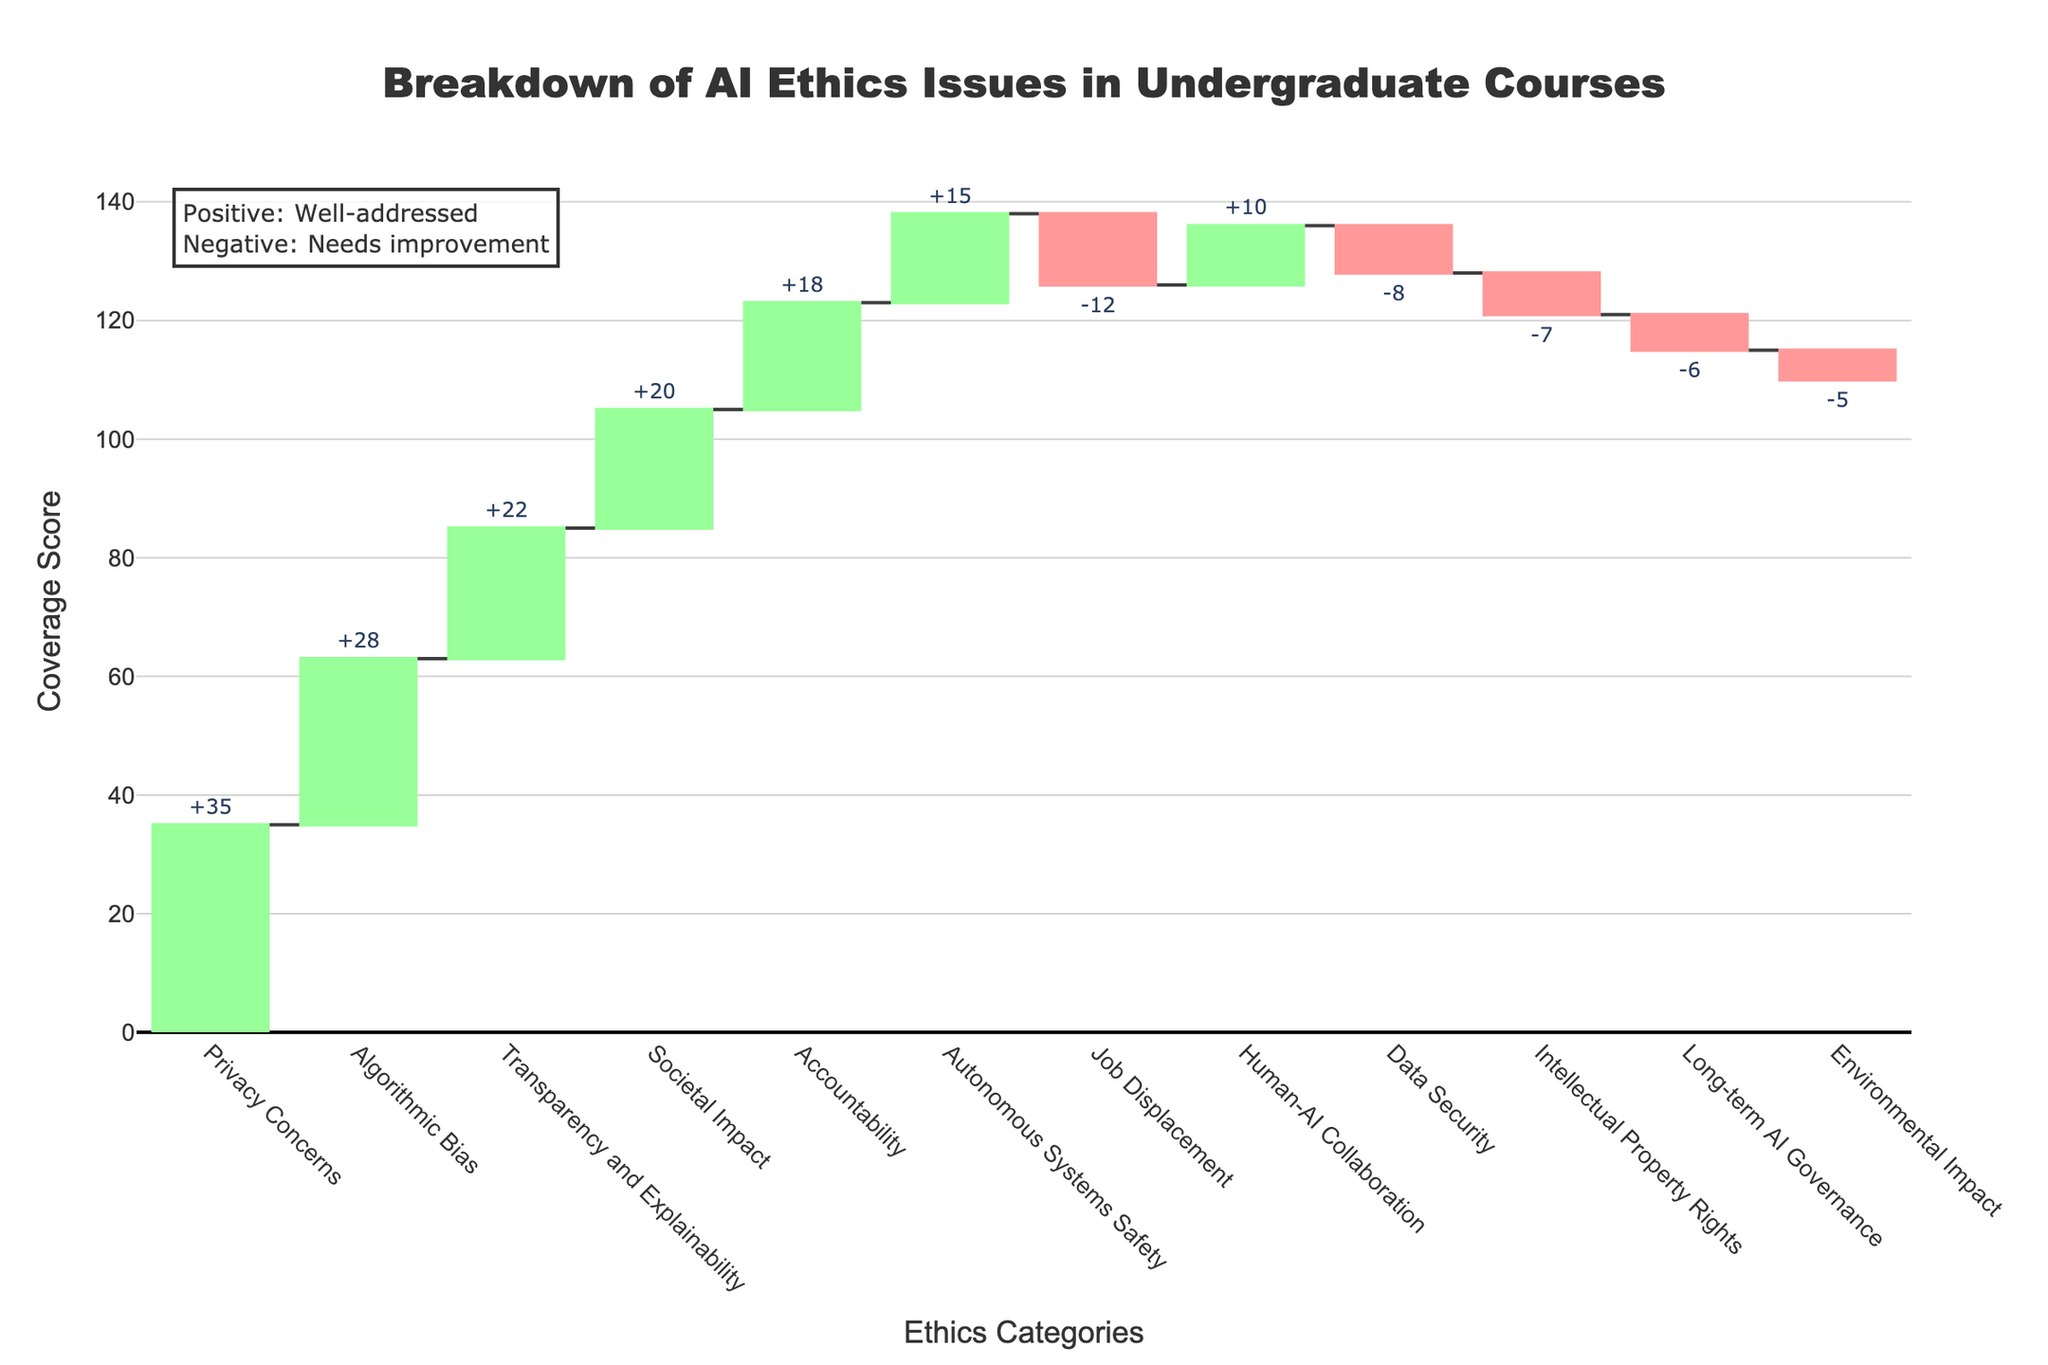Which category has the highest coverage score? The category with the highest coverage score is indicated by the tallest bar. In this case, "Privacy Concerns" has the highest score of +35.
Answer: Privacy Concerns Which category has the lowest coverage score? The category with the lowest score is indicated by the lowest bar. "Job Displacement" has the lowest score of -12.
Answer: Job Displacement What is the total number of categories represented in the chart? Count all the unique categories on the x-axis. There are 12 categories.
Answer: 12 How many categories have a negative coverage score? Look for the categories with negative values (red bars). There are 5 categories with negative coverage scores: Data Security, Job Displacement, Environmental Impact, Intellectual Property Rights, and Long-term AI Governance.
Answer: 5 Which category related to human interaction has a positive coverage score? Categories related to human interaction include Human-AI Collaboration and Societal Impact. Both categories have positive scores, with Human-AI Collaboration at +10 and Societal Impact at +20.
Answer: Human-AI Collaboration, Societal Impact What is the combined coverage score for "Algorithmic Bias," "Transparency and Explainability," and "Accountability"? Sum the values of these categories: 28 (Algorithmic Bias) + 22 (Transparency and Explainability) + 18 (Accountability) = 68.
Answer: 68 How does the coverage of "Data Security" compare to "Intellectual Property Rights"? "Data Security" has a score of -8, which is one point better than "Intellectual Property Rights," which has a score of -7.
Answer: Data Security is one point worse than Intellectual Property Rights Which category addresses the safety of autonomous systems, and what is its coverage score? The category that addresses the safety of autonomous systems is "Autonomous Systems Safety," and its coverage score is +15.
Answer: Autonomous Systems Safety, +15 What can you infer about the importance placed on the "Societal Impact" of AI ethics in undergraduate courses? "Societal Impact" has a high positive coverage score of +20, indicating that considerable importance is placed on this category in undergraduate courses.
Answer: High importance 